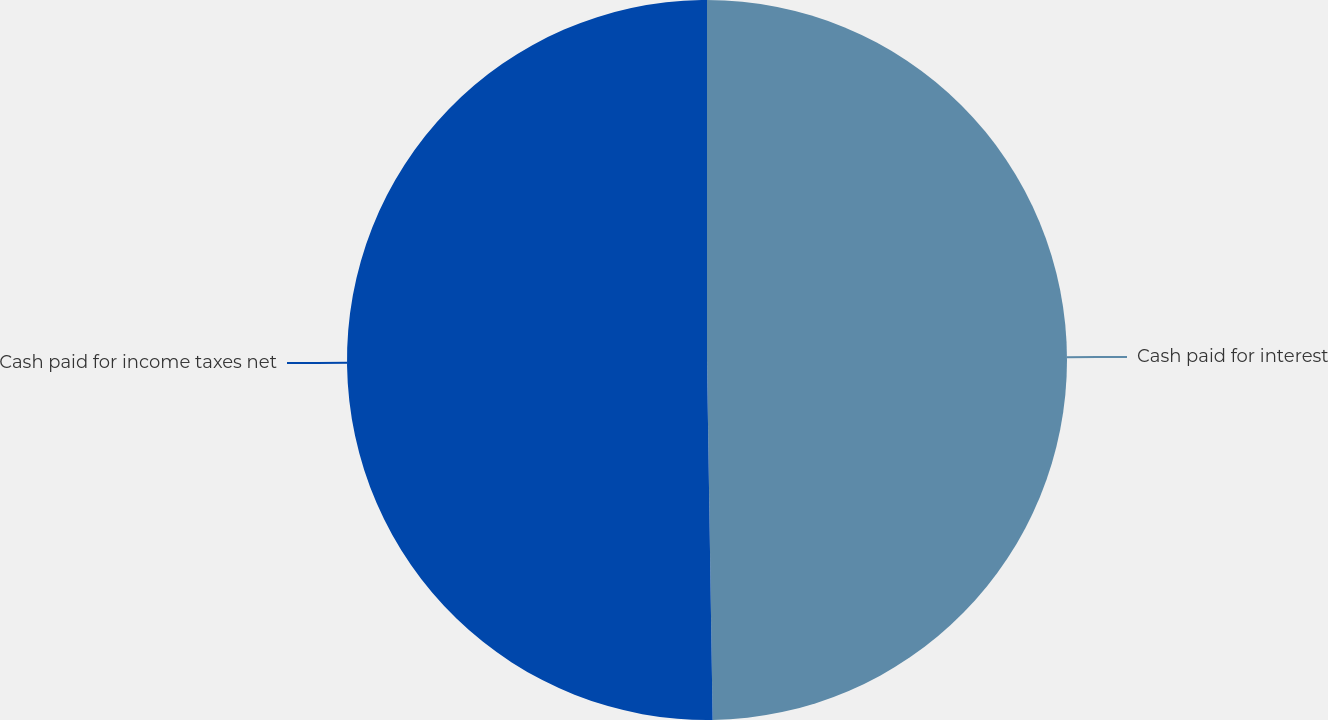<chart> <loc_0><loc_0><loc_500><loc_500><pie_chart><fcel>Cash paid for interest<fcel>Cash paid for income taxes net<nl><fcel>49.75%<fcel>50.25%<nl></chart> 